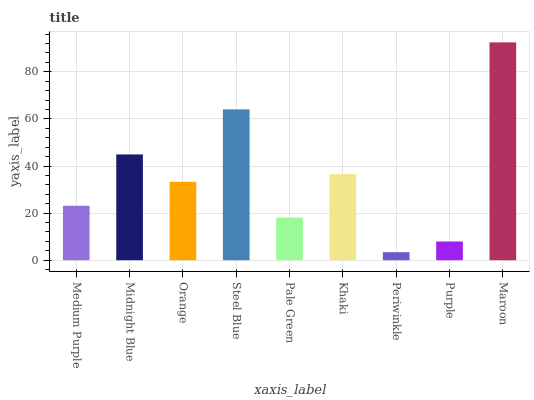Is Periwinkle the minimum?
Answer yes or no. Yes. Is Maroon the maximum?
Answer yes or no. Yes. Is Midnight Blue the minimum?
Answer yes or no. No. Is Midnight Blue the maximum?
Answer yes or no. No. Is Midnight Blue greater than Medium Purple?
Answer yes or no. Yes. Is Medium Purple less than Midnight Blue?
Answer yes or no. Yes. Is Medium Purple greater than Midnight Blue?
Answer yes or no. No. Is Midnight Blue less than Medium Purple?
Answer yes or no. No. Is Orange the high median?
Answer yes or no. Yes. Is Orange the low median?
Answer yes or no. Yes. Is Purple the high median?
Answer yes or no. No. Is Medium Purple the low median?
Answer yes or no. No. 